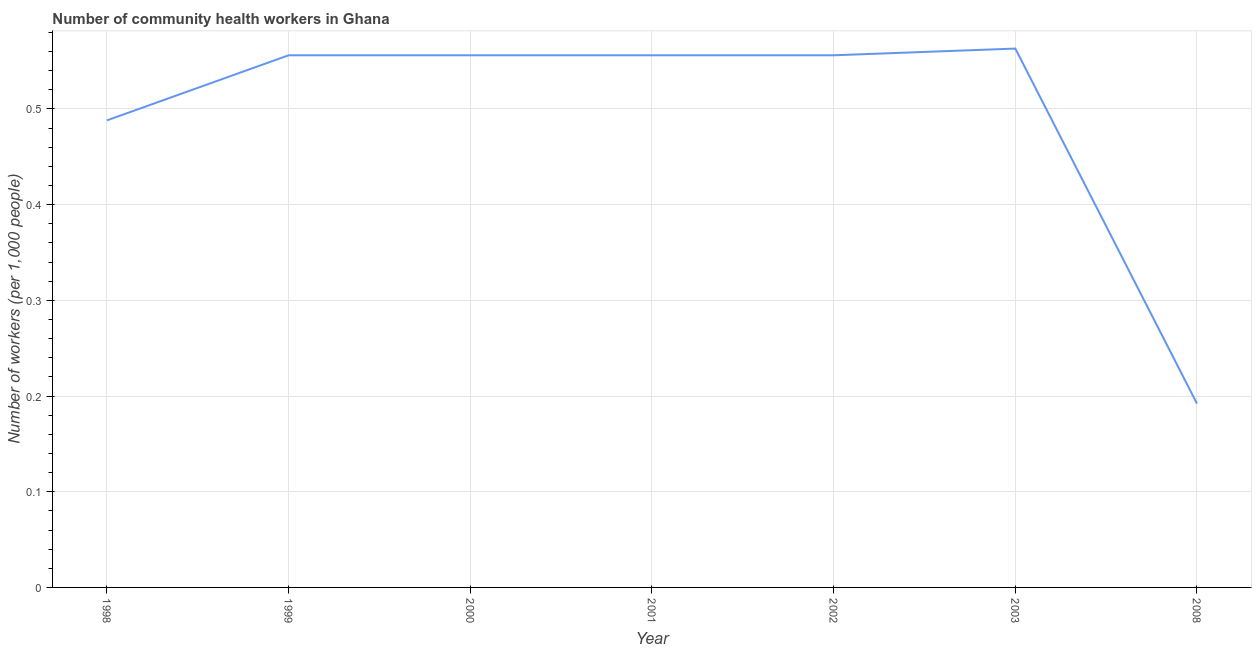What is the number of community health workers in 2001?
Keep it short and to the point. 0.56. Across all years, what is the maximum number of community health workers?
Offer a very short reply. 0.56. Across all years, what is the minimum number of community health workers?
Provide a succinct answer. 0.19. In which year was the number of community health workers maximum?
Your answer should be very brief. 2003. In which year was the number of community health workers minimum?
Ensure brevity in your answer.  2008. What is the sum of the number of community health workers?
Give a very brief answer. 3.47. What is the difference between the number of community health workers in 2002 and 2008?
Offer a terse response. 0.36. What is the average number of community health workers per year?
Your response must be concise. 0.5. What is the median number of community health workers?
Make the answer very short. 0.56. In how many years, is the number of community health workers greater than 0.2 ?
Keep it short and to the point. 6. Do a majority of the years between 1998 and 1999 (inclusive) have number of community health workers greater than 0.5 ?
Provide a succinct answer. No. What is the ratio of the number of community health workers in 2000 to that in 2003?
Provide a succinct answer. 0.99. Is the number of community health workers in 1999 less than that in 2001?
Make the answer very short. No. What is the difference between the highest and the second highest number of community health workers?
Keep it short and to the point. 0.01. What is the difference between the highest and the lowest number of community health workers?
Keep it short and to the point. 0.37. Does the number of community health workers monotonically increase over the years?
Your answer should be compact. No. How many lines are there?
Provide a succinct answer. 1. What is the difference between two consecutive major ticks on the Y-axis?
Offer a very short reply. 0.1. Does the graph contain grids?
Your answer should be compact. Yes. What is the title of the graph?
Provide a short and direct response. Number of community health workers in Ghana. What is the label or title of the X-axis?
Offer a terse response. Year. What is the label or title of the Y-axis?
Ensure brevity in your answer.  Number of workers (per 1,0 people). What is the Number of workers (per 1,000 people) in 1998?
Offer a terse response. 0.49. What is the Number of workers (per 1,000 people) in 1999?
Provide a short and direct response. 0.56. What is the Number of workers (per 1,000 people) of 2000?
Offer a very short reply. 0.56. What is the Number of workers (per 1,000 people) of 2001?
Make the answer very short. 0.56. What is the Number of workers (per 1,000 people) of 2002?
Keep it short and to the point. 0.56. What is the Number of workers (per 1,000 people) in 2003?
Your response must be concise. 0.56. What is the Number of workers (per 1,000 people) of 2008?
Make the answer very short. 0.19. What is the difference between the Number of workers (per 1,000 people) in 1998 and 1999?
Offer a very short reply. -0.07. What is the difference between the Number of workers (per 1,000 people) in 1998 and 2000?
Ensure brevity in your answer.  -0.07. What is the difference between the Number of workers (per 1,000 people) in 1998 and 2001?
Provide a succinct answer. -0.07. What is the difference between the Number of workers (per 1,000 people) in 1998 and 2002?
Provide a short and direct response. -0.07. What is the difference between the Number of workers (per 1,000 people) in 1998 and 2003?
Offer a terse response. -0.07. What is the difference between the Number of workers (per 1,000 people) in 1998 and 2008?
Your answer should be compact. 0.3. What is the difference between the Number of workers (per 1,000 people) in 1999 and 2002?
Offer a terse response. 0. What is the difference between the Number of workers (per 1,000 people) in 1999 and 2003?
Your response must be concise. -0.01. What is the difference between the Number of workers (per 1,000 people) in 1999 and 2008?
Your answer should be very brief. 0.36. What is the difference between the Number of workers (per 1,000 people) in 2000 and 2003?
Your answer should be compact. -0.01. What is the difference between the Number of workers (per 1,000 people) in 2000 and 2008?
Offer a terse response. 0.36. What is the difference between the Number of workers (per 1,000 people) in 2001 and 2003?
Ensure brevity in your answer.  -0.01. What is the difference between the Number of workers (per 1,000 people) in 2001 and 2008?
Provide a short and direct response. 0.36. What is the difference between the Number of workers (per 1,000 people) in 2002 and 2003?
Your answer should be compact. -0.01. What is the difference between the Number of workers (per 1,000 people) in 2002 and 2008?
Offer a terse response. 0.36. What is the difference between the Number of workers (per 1,000 people) in 2003 and 2008?
Provide a short and direct response. 0.37. What is the ratio of the Number of workers (per 1,000 people) in 1998 to that in 1999?
Make the answer very short. 0.88. What is the ratio of the Number of workers (per 1,000 people) in 1998 to that in 2000?
Give a very brief answer. 0.88. What is the ratio of the Number of workers (per 1,000 people) in 1998 to that in 2001?
Give a very brief answer. 0.88. What is the ratio of the Number of workers (per 1,000 people) in 1998 to that in 2002?
Keep it short and to the point. 0.88. What is the ratio of the Number of workers (per 1,000 people) in 1998 to that in 2003?
Give a very brief answer. 0.87. What is the ratio of the Number of workers (per 1,000 people) in 1998 to that in 2008?
Your answer should be compact. 2.54. What is the ratio of the Number of workers (per 1,000 people) in 1999 to that in 2000?
Give a very brief answer. 1. What is the ratio of the Number of workers (per 1,000 people) in 1999 to that in 2001?
Your answer should be compact. 1. What is the ratio of the Number of workers (per 1,000 people) in 1999 to that in 2002?
Offer a terse response. 1. What is the ratio of the Number of workers (per 1,000 people) in 1999 to that in 2003?
Offer a very short reply. 0.99. What is the ratio of the Number of workers (per 1,000 people) in 1999 to that in 2008?
Provide a short and direct response. 2.9. What is the ratio of the Number of workers (per 1,000 people) in 2000 to that in 2001?
Your answer should be very brief. 1. What is the ratio of the Number of workers (per 1,000 people) in 2000 to that in 2002?
Ensure brevity in your answer.  1. What is the ratio of the Number of workers (per 1,000 people) in 2000 to that in 2008?
Your response must be concise. 2.9. What is the ratio of the Number of workers (per 1,000 people) in 2001 to that in 2003?
Your answer should be very brief. 0.99. What is the ratio of the Number of workers (per 1,000 people) in 2001 to that in 2008?
Offer a very short reply. 2.9. What is the ratio of the Number of workers (per 1,000 people) in 2002 to that in 2003?
Keep it short and to the point. 0.99. What is the ratio of the Number of workers (per 1,000 people) in 2002 to that in 2008?
Make the answer very short. 2.9. What is the ratio of the Number of workers (per 1,000 people) in 2003 to that in 2008?
Keep it short and to the point. 2.93. 